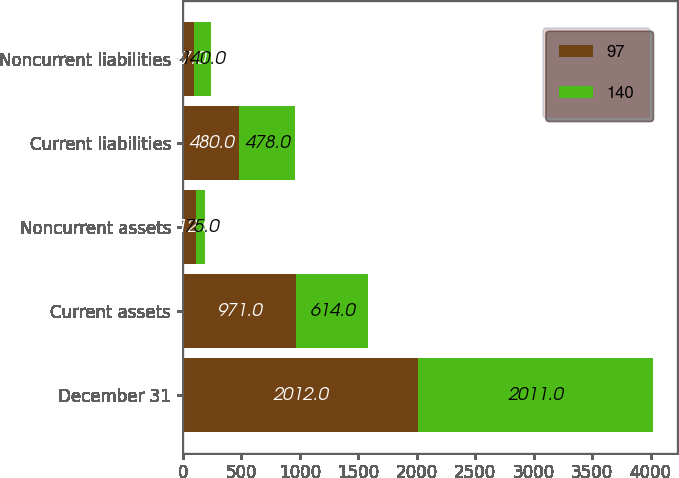Convert chart to OTSL. <chart><loc_0><loc_0><loc_500><loc_500><stacked_bar_chart><ecel><fcel>December 31<fcel>Current assets<fcel>Noncurrent assets<fcel>Current liabilities<fcel>Noncurrent liabilities<nl><fcel>97<fcel>2012<fcel>971<fcel>112<fcel>480<fcel>97<nl><fcel>140<fcel>2011<fcel>614<fcel>75<fcel>478<fcel>140<nl></chart> 